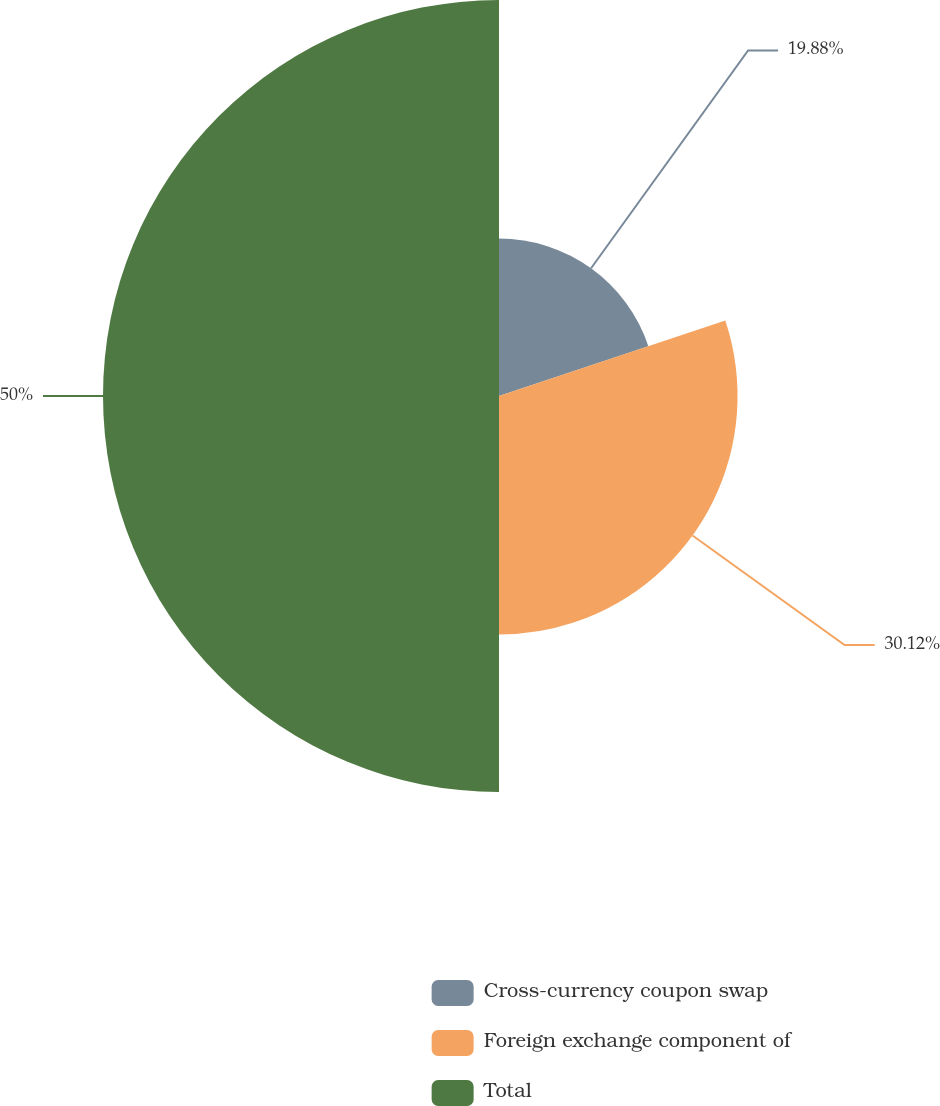Convert chart to OTSL. <chart><loc_0><loc_0><loc_500><loc_500><pie_chart><fcel>Cross-currency coupon swap<fcel>Foreign exchange component of<fcel>Total<nl><fcel>19.88%<fcel>30.12%<fcel>50.0%<nl></chart> 